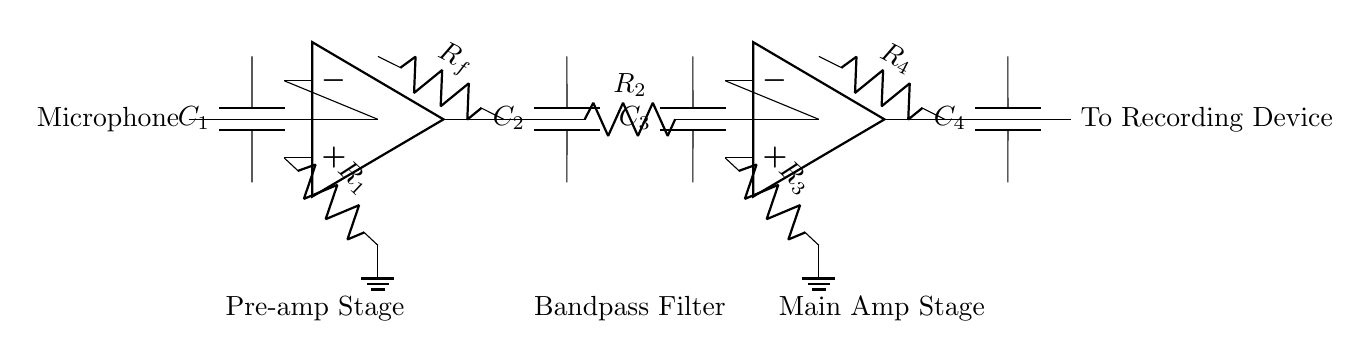What type of amplifier is used in this circuit? The circuit uses two operational amplifiers (op amps) in the pre-amplifier and main amplifier stages.
Answer: operational amplifier What component is used to block DC in the input stage? The capacitor C1 is present in the input stage to block DC while allowing AC signals to pass through.
Answer: C1 How many resistors are present in the main amplifier stage? In the main amplifier stage, there are two resistors: R3 and R4.
Answer: 2 What is the purpose of the bandpass filter in this circuit? The bandpass filter, composed of capacitors C2, C3, and resistor R2, allows signals within a specific frequency range to pass while attenuating signals outside of that range.
Answer: frequency filtering Which component is placed directly after the pre-amplifier? The bandpass filter follows the pre-amplifier stage directly in the signal path.
Answer: bandpass filter How many capacitors are there in total in the circuit? The circuit contains four capacitors: C1, C2, C3, and C4.
Answer: 4 What does the output of the circuit connect to? The output of the circuit connects to a recording device, where the amplified audio signal is sent for further processing or storage.
Answer: To Recording Device 